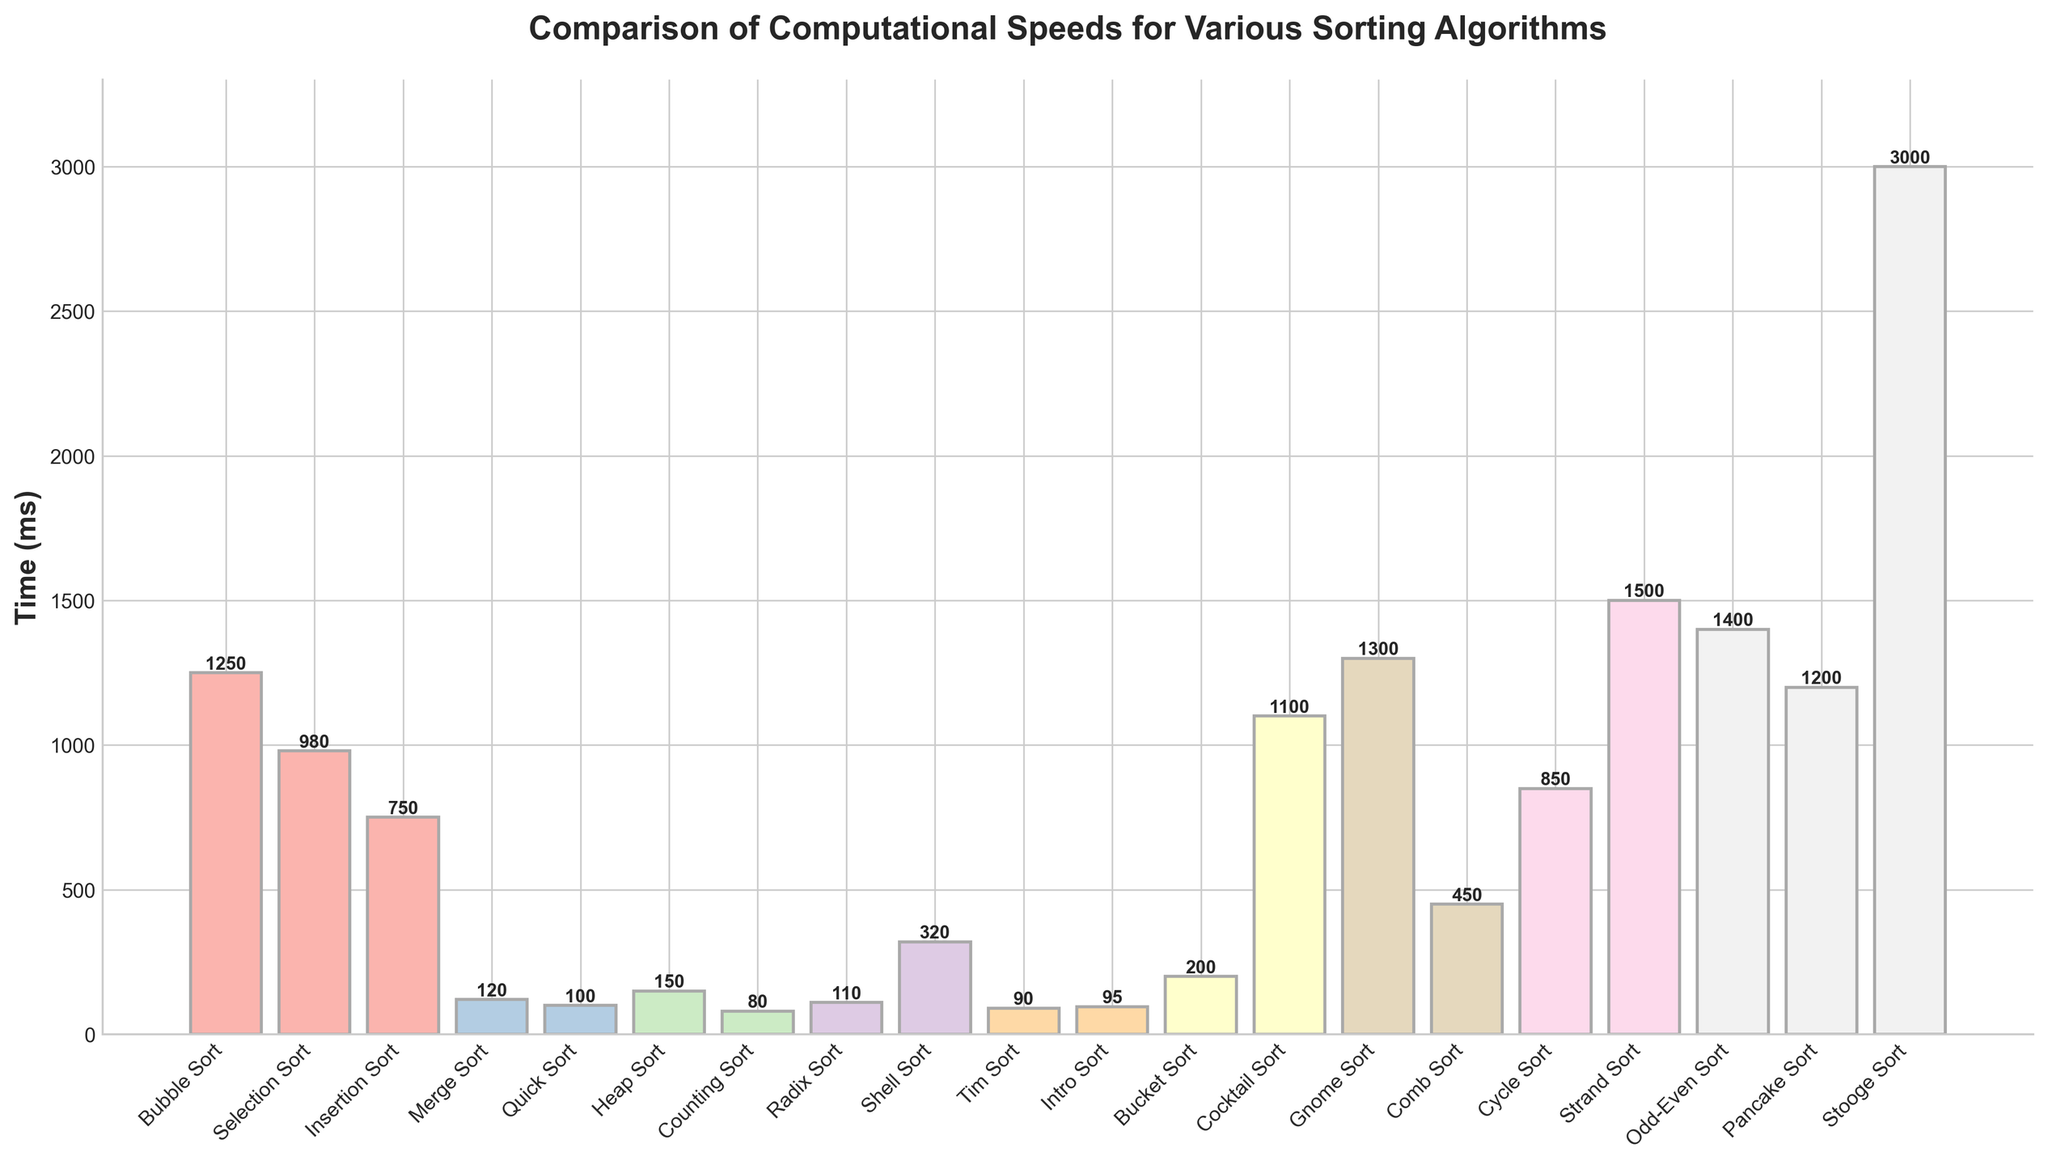What is the fastest sorting algorithm based on the computational speeds? By inspecting the bar chart, we can see that the height of the bars represents the computational time in milliseconds. The shortest bar corresponds to the algorithm with the fastest speed. The shortest bar is for Counting Sort with a time of 80 ms.
Answer: Counting Sort Which sorting algorithm has the highest computational time? In the bar chart, the highest bar represents the algorithm with the largest computational time. The bar for Stooge Sort is the highest with a time of 3000 ms.
Answer: Stooge Sort How much faster is Quick Sort compared to Bubble Sort? By comparing the heights of the bars for Quick Sort and Bubble Sort, we see the computational times are 100 ms and 1250 ms respectively. The difference is 1250 - 100 = 1150 ms.
Answer: 1150 ms Which sorting algorithms have a computational time of less than 200 ms? By examining the height of each bar, we identify the bars with heights below 200 ms. These are Counting Sort (80 ms), Tim Sort (90 ms), Intro Sort (95 ms), Quick Sort (100 ms), Radix Sort (110 ms), and Merge Sort (120 ms).
Answer: Counting Sort, Tim Sort, Intro Sort, Quick Sort, Radix Sort, Merge Sort What's the average computational time of Bubble Sort, Selection Sort, and Insertion Sort? By summing the computational times of Bubble Sort (1250 ms), Selection Sort (980 ms), and Insertion Sort (750 ms) and then dividing by 3, the average is (1250 + 980 + 750) / 3 = 330 ms.
Answer: 993.33 ms Which algorithm is slower, Cycle Sort or Pancake Sort? By comparing the heights of the bars for Cycle Sort (850 ms) and Pancake Sort (1200 ms), we see that Pancake Sort's bar is higher, indicating it is slower.
Answer: Pancake Sort Ordering the sorting algorithms in descending order of computational time, which algorithm appears third? By arranging the bars in descending order of height, the third highest bar corresponds to the algorithm with the third highest computational time, which is Odd-Even Sort with a time of 1400 ms.
Answer: Odd-Even Sort What is the median computational time of all the sorting algorithms? To find the median, list all computational times and find the middle value. Sorted times in ascending order: 80, 90, 95, 100, 110, 120, 150, 200, 320, 450, 750, 850, 980, 1100, 1200, 1250, 1300, 1400, 1500, 3000. The median of 20 values is the average of the 10th and 11th values: (750 + 320)/2 = 535 ms.
Answer: 535 ms 